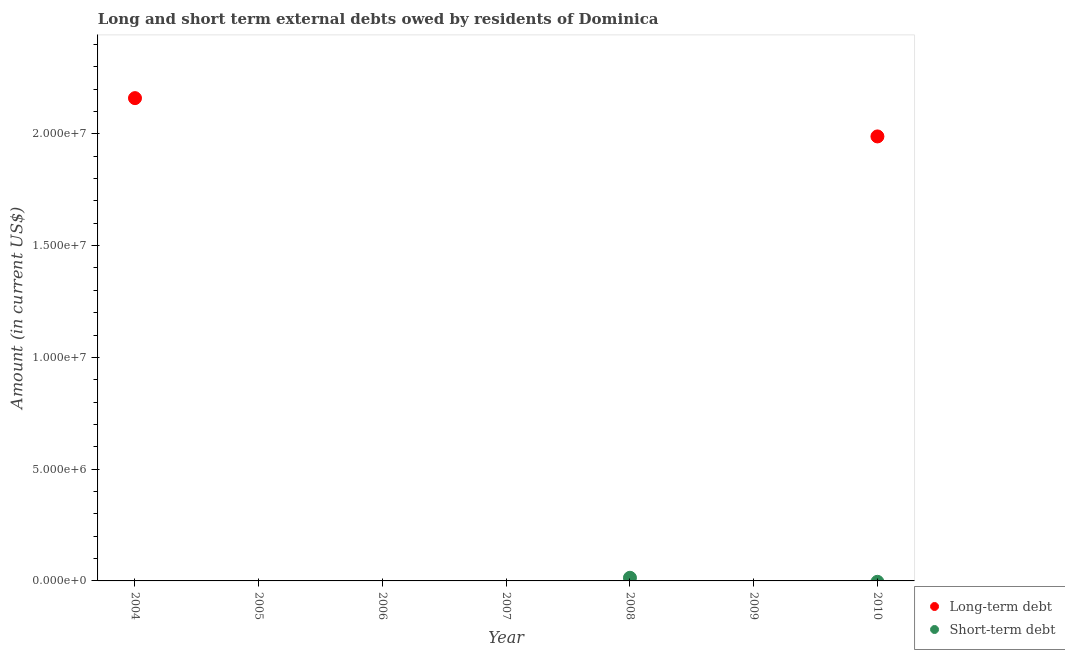Across all years, what is the maximum short-term debts owed by residents?
Your answer should be very brief. 1.40e+05. In which year was the long-term debts owed by residents maximum?
Your answer should be very brief. 2004. What is the total long-term debts owed by residents in the graph?
Offer a terse response. 4.15e+07. What is the difference between the long-term debts owed by residents in 2006 and the short-term debts owed by residents in 2005?
Ensure brevity in your answer.  0. What is the average long-term debts owed by residents per year?
Your answer should be compact. 5.93e+06. What is the difference between the highest and the lowest long-term debts owed by residents?
Your answer should be very brief. 2.16e+07. In how many years, is the short-term debts owed by residents greater than the average short-term debts owed by residents taken over all years?
Provide a short and direct response. 1. Is the short-term debts owed by residents strictly greater than the long-term debts owed by residents over the years?
Your answer should be compact. No. How many dotlines are there?
Provide a short and direct response. 2. How many years are there in the graph?
Your answer should be compact. 7. What is the difference between two consecutive major ticks on the Y-axis?
Provide a succinct answer. 5.00e+06. Are the values on the major ticks of Y-axis written in scientific E-notation?
Your answer should be very brief. Yes. Does the graph contain any zero values?
Your answer should be compact. Yes. Where does the legend appear in the graph?
Your answer should be compact. Bottom right. How many legend labels are there?
Keep it short and to the point. 2. What is the title of the graph?
Your answer should be very brief. Long and short term external debts owed by residents of Dominica. What is the label or title of the X-axis?
Provide a short and direct response. Year. What is the Amount (in current US$) in Long-term debt in 2004?
Offer a terse response. 2.16e+07. What is the Amount (in current US$) in Short-term debt in 2004?
Your answer should be compact. 0. What is the Amount (in current US$) in Long-term debt in 2005?
Your answer should be compact. 0. What is the Amount (in current US$) of Short-term debt in 2005?
Your answer should be compact. 0. What is the Amount (in current US$) in Short-term debt in 2007?
Provide a short and direct response. 0. What is the Amount (in current US$) of Short-term debt in 2008?
Give a very brief answer. 1.40e+05. What is the Amount (in current US$) in Short-term debt in 2009?
Make the answer very short. 0. What is the Amount (in current US$) in Long-term debt in 2010?
Your response must be concise. 1.99e+07. Across all years, what is the maximum Amount (in current US$) of Long-term debt?
Give a very brief answer. 2.16e+07. Across all years, what is the minimum Amount (in current US$) in Long-term debt?
Ensure brevity in your answer.  0. What is the total Amount (in current US$) of Long-term debt in the graph?
Your answer should be very brief. 4.15e+07. What is the total Amount (in current US$) of Short-term debt in the graph?
Provide a succinct answer. 1.40e+05. What is the difference between the Amount (in current US$) in Long-term debt in 2004 and that in 2010?
Offer a terse response. 1.71e+06. What is the difference between the Amount (in current US$) in Long-term debt in 2004 and the Amount (in current US$) in Short-term debt in 2008?
Provide a succinct answer. 2.15e+07. What is the average Amount (in current US$) of Long-term debt per year?
Your response must be concise. 5.93e+06. What is the average Amount (in current US$) of Short-term debt per year?
Ensure brevity in your answer.  2.00e+04. What is the ratio of the Amount (in current US$) of Long-term debt in 2004 to that in 2010?
Offer a very short reply. 1.09. What is the difference between the highest and the lowest Amount (in current US$) of Long-term debt?
Give a very brief answer. 2.16e+07. What is the difference between the highest and the lowest Amount (in current US$) of Short-term debt?
Your answer should be compact. 1.40e+05. 